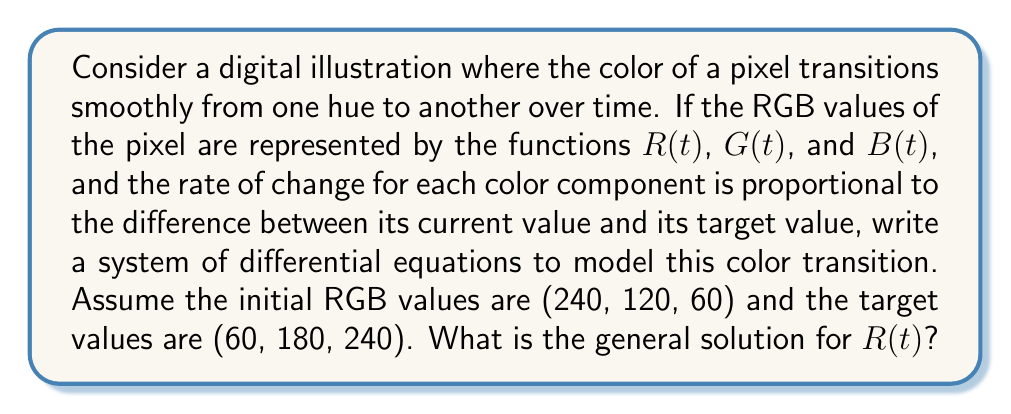What is the answer to this math problem? Let's approach this step-by-step:

1) First, we need to set up our differential equations. The rate of change for each color component is proportional to the difference between its current value and its target value. This can be expressed as:

   $$\frac{dR}{dt} = k(R_{target} - R)$$
   $$\frac{dG}{dt} = k(G_{target} - G)$$
   $$\frac{dB}{dt} = k(B_{target} - B)$$

   where $k$ is a positive constant that determines the speed of the transition.

2) For the red component, we have:
   
   $$\frac{dR}{dt} = k(60 - R)$$

3) This is a first-order linear differential equation. The general solution for such an equation is:

   $$R(t) = Ce^{-kt} + R_{target}$$

   where $C$ is a constant determined by the initial conditions.

4) We know that at $t=0$, $R(0) = 240$. Let's use this to find $C$:

   $$240 = Ce^{0} + 60$$
   $$C = 180$$

5) Therefore, the general solution for $R(t)$ is:

   $$R(t) = 180e^{-kt} + 60$$

This equation describes how the red component of the pixel's color changes over time, starting at 240 and approaching 60 as $t$ increases.
Answer: $$R(t) = 180e^{-kt} + 60$$ 